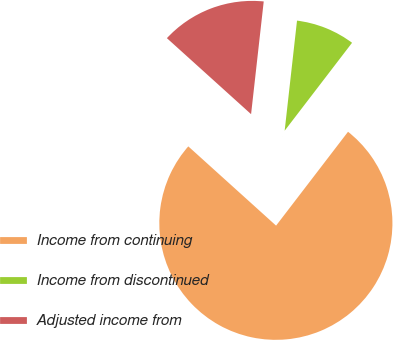Convert chart to OTSL. <chart><loc_0><loc_0><loc_500><loc_500><pie_chart><fcel>Income from continuing<fcel>Income from discontinued<fcel>Adjusted income from<nl><fcel>76.28%<fcel>8.63%<fcel>15.09%<nl></chart> 